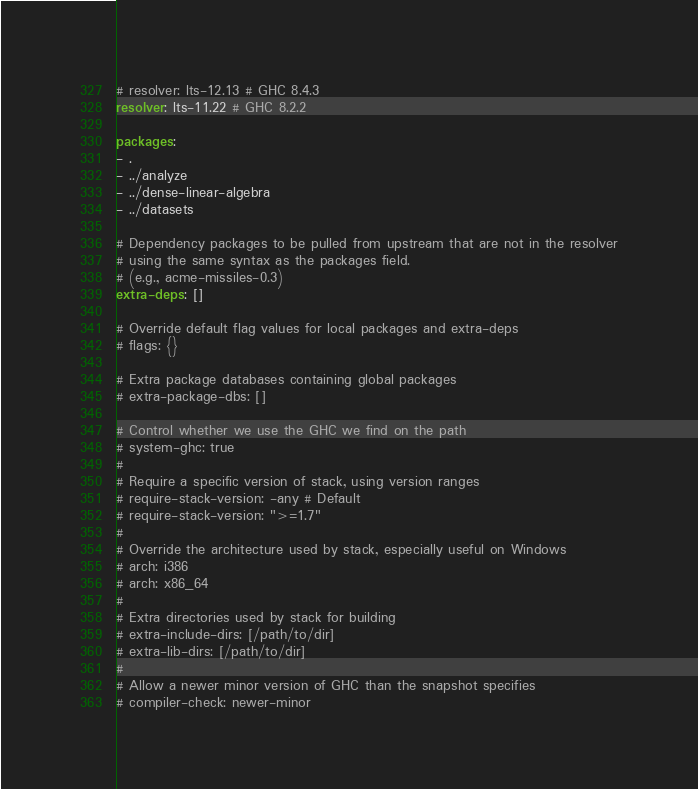Convert code to text. <code><loc_0><loc_0><loc_500><loc_500><_YAML_># resolver: lts-12.13 # GHC 8.4.3
resolver: lts-11.22 # GHC 8.2.2

packages:
- .
- ../analyze
- ../dense-linear-algebra
- ../datasets

# Dependency packages to be pulled from upstream that are not in the resolver
# using the same syntax as the packages field.
# (e.g., acme-missiles-0.3)
extra-deps: []

# Override default flag values for local packages and extra-deps
# flags: {}

# Extra package databases containing global packages
# extra-package-dbs: []

# Control whether we use the GHC we find on the path
# system-ghc: true
#
# Require a specific version of stack, using version ranges
# require-stack-version: -any # Default
# require-stack-version: ">=1.7"
#
# Override the architecture used by stack, especially useful on Windows
# arch: i386
# arch: x86_64
#
# Extra directories used by stack for building
# extra-include-dirs: [/path/to/dir]
# extra-lib-dirs: [/path/to/dir]
#
# Allow a newer minor version of GHC than the snapshot specifies
# compiler-check: newer-minor
</code> 